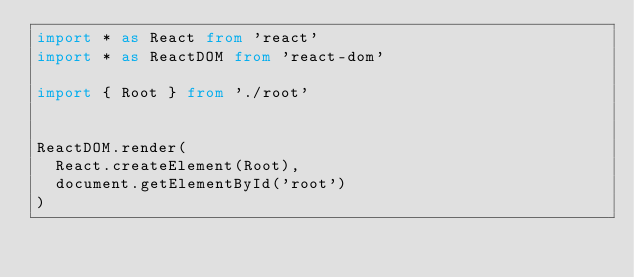Convert code to text. <code><loc_0><loc_0><loc_500><loc_500><_TypeScript_>import * as React from 'react'
import * as ReactDOM from 'react-dom'

import { Root } from './root'


ReactDOM.render(
  React.createElement(Root),
  document.getElementById('root')
)
</code> 